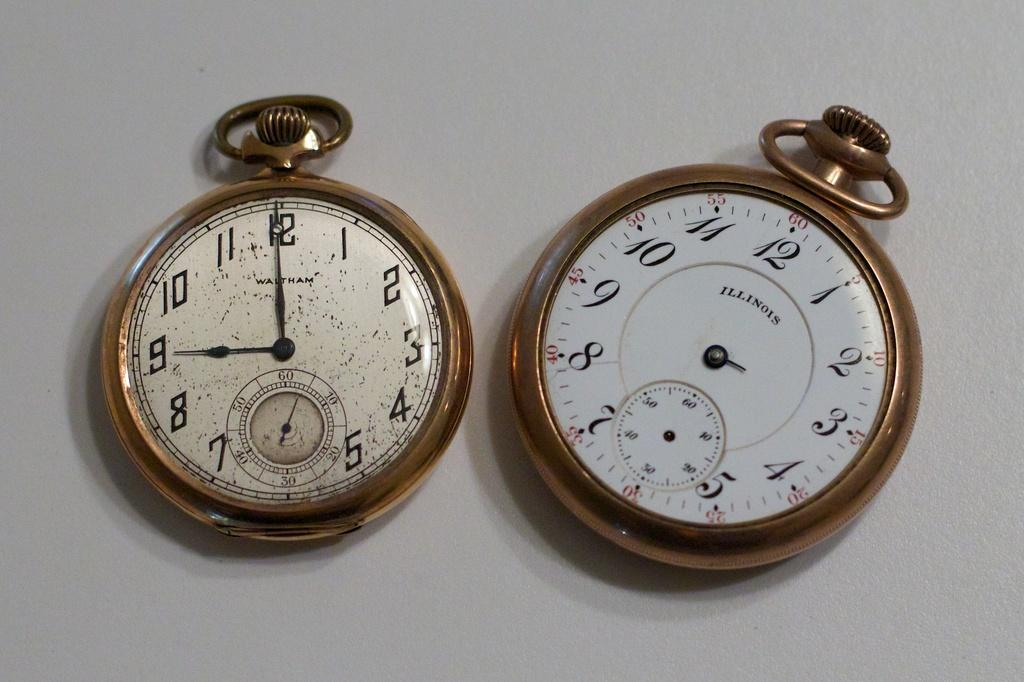Provide a one-sentence caption for the provided image. Two stop watches right next to one another with one saying Illinois on the face. 